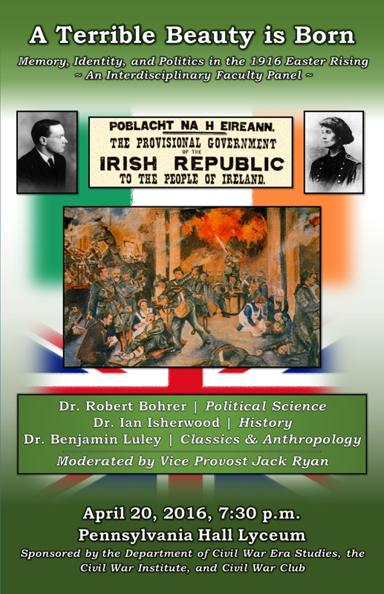Could you tell me more about the significance of the 1916 Easter Rising in Irish history? The 1916 Easter Rising was a pivotal event in Irish history, marking a six-day insurrection against British rule. It played a crucial role in revitalizing Irish nationalism, leading to the country's eventual independence. The Rising is often remembered for its dramatic call to arms and the subsequent martyrdom of its leaders, which were instrumental in mobilizing the Irish population for the cause of independence. 